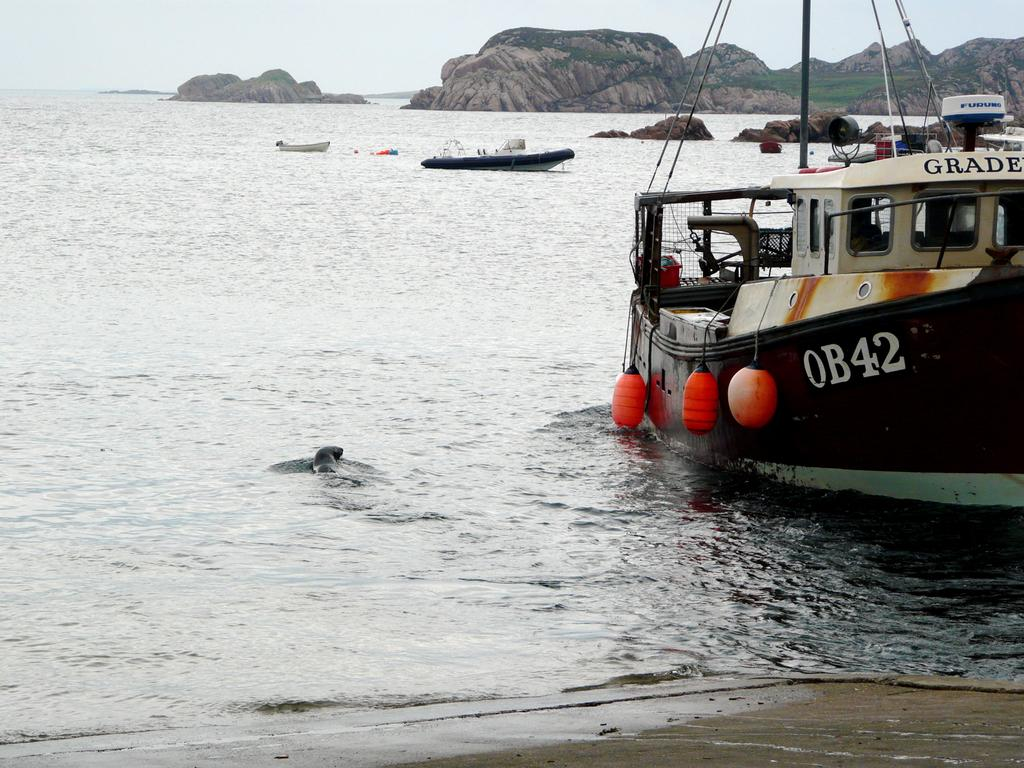What type of vehicles can be seen in the image? There are boats in the image. What body of water is present in the image? There is a sea in the image. What type of landscape can be seen in the background of the image? There are hills in the background of the image. What is visible in the sky in the image? The sky is visible in the background of the image. Where is the frog sitting in the image? There is no frog present in the image. What type of calculator can be seen on the hill in the image? There is no calculator present in the image. 